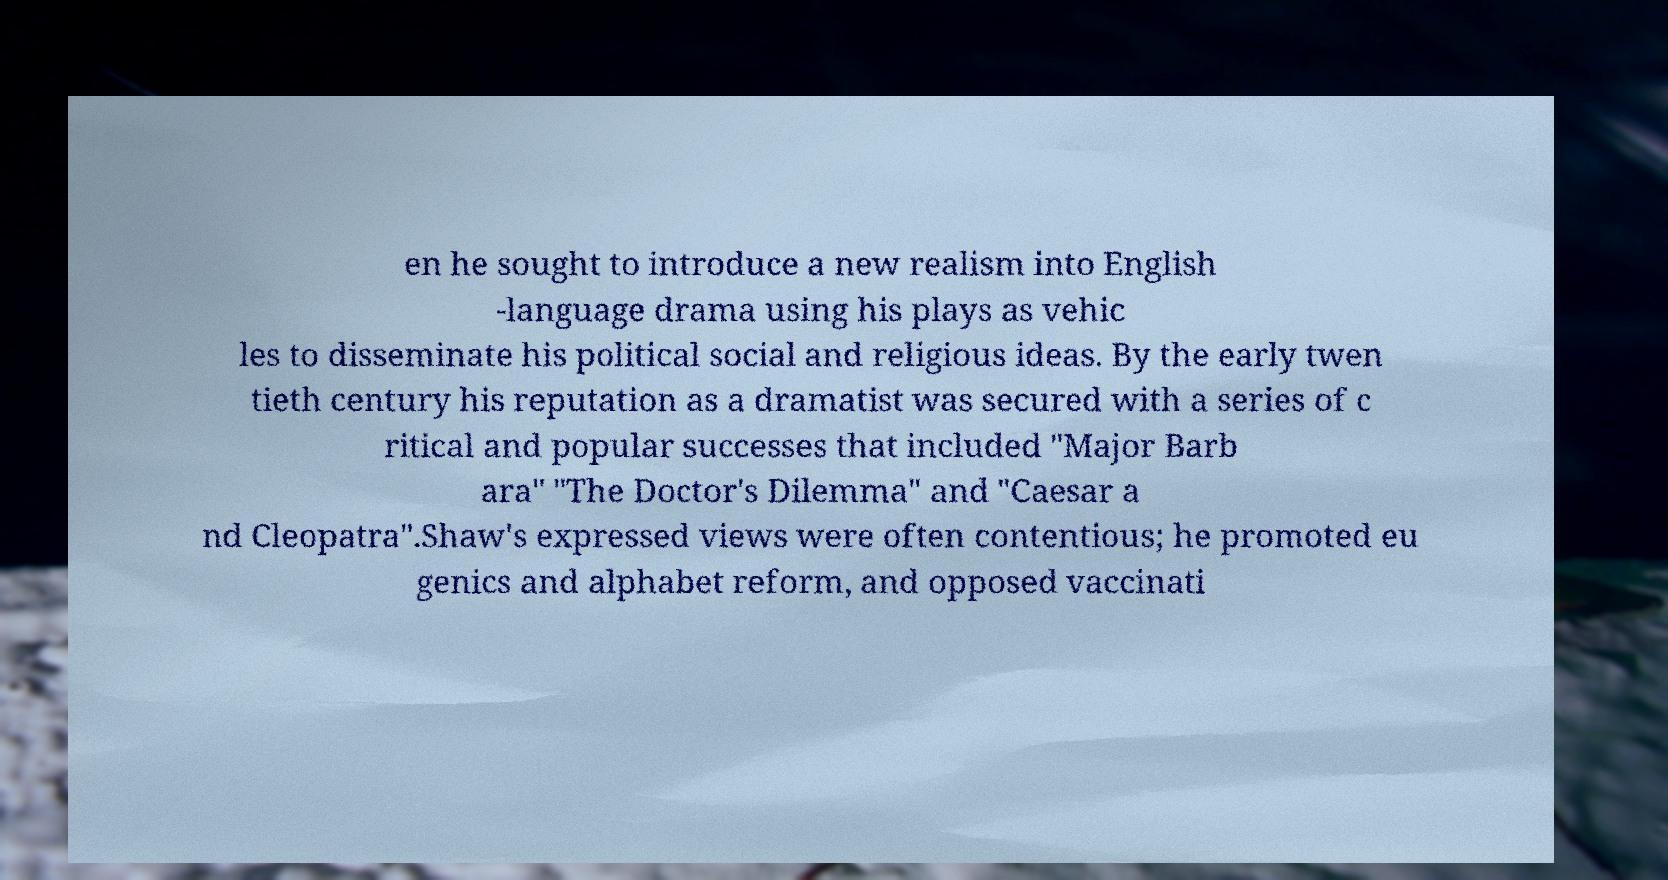Could you extract and type out the text from this image? en he sought to introduce a new realism into English -language drama using his plays as vehic les to disseminate his political social and religious ideas. By the early twen tieth century his reputation as a dramatist was secured with a series of c ritical and popular successes that included "Major Barb ara" "The Doctor's Dilemma" and "Caesar a nd Cleopatra".Shaw's expressed views were often contentious; he promoted eu genics and alphabet reform, and opposed vaccinati 